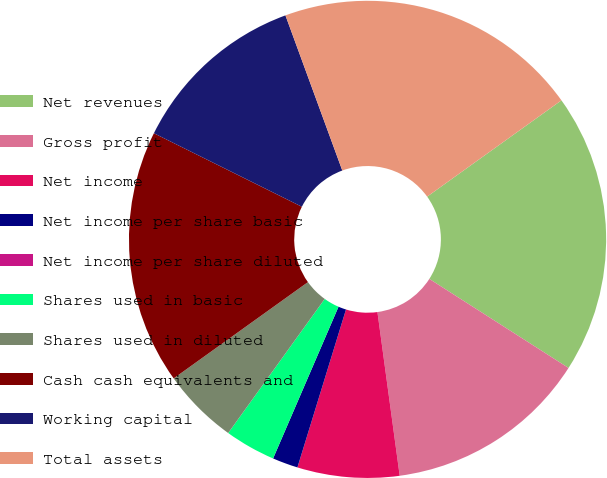Convert chart to OTSL. <chart><loc_0><loc_0><loc_500><loc_500><pie_chart><fcel>Net revenues<fcel>Gross profit<fcel>Net income<fcel>Net income per share basic<fcel>Net income per share diluted<fcel>Shares used in basic<fcel>Shares used in diluted<fcel>Cash cash equivalents and<fcel>Working capital<fcel>Total assets<nl><fcel>18.96%<fcel>13.79%<fcel>6.9%<fcel>1.73%<fcel>0.0%<fcel>3.45%<fcel>5.17%<fcel>17.24%<fcel>12.07%<fcel>20.69%<nl></chart> 